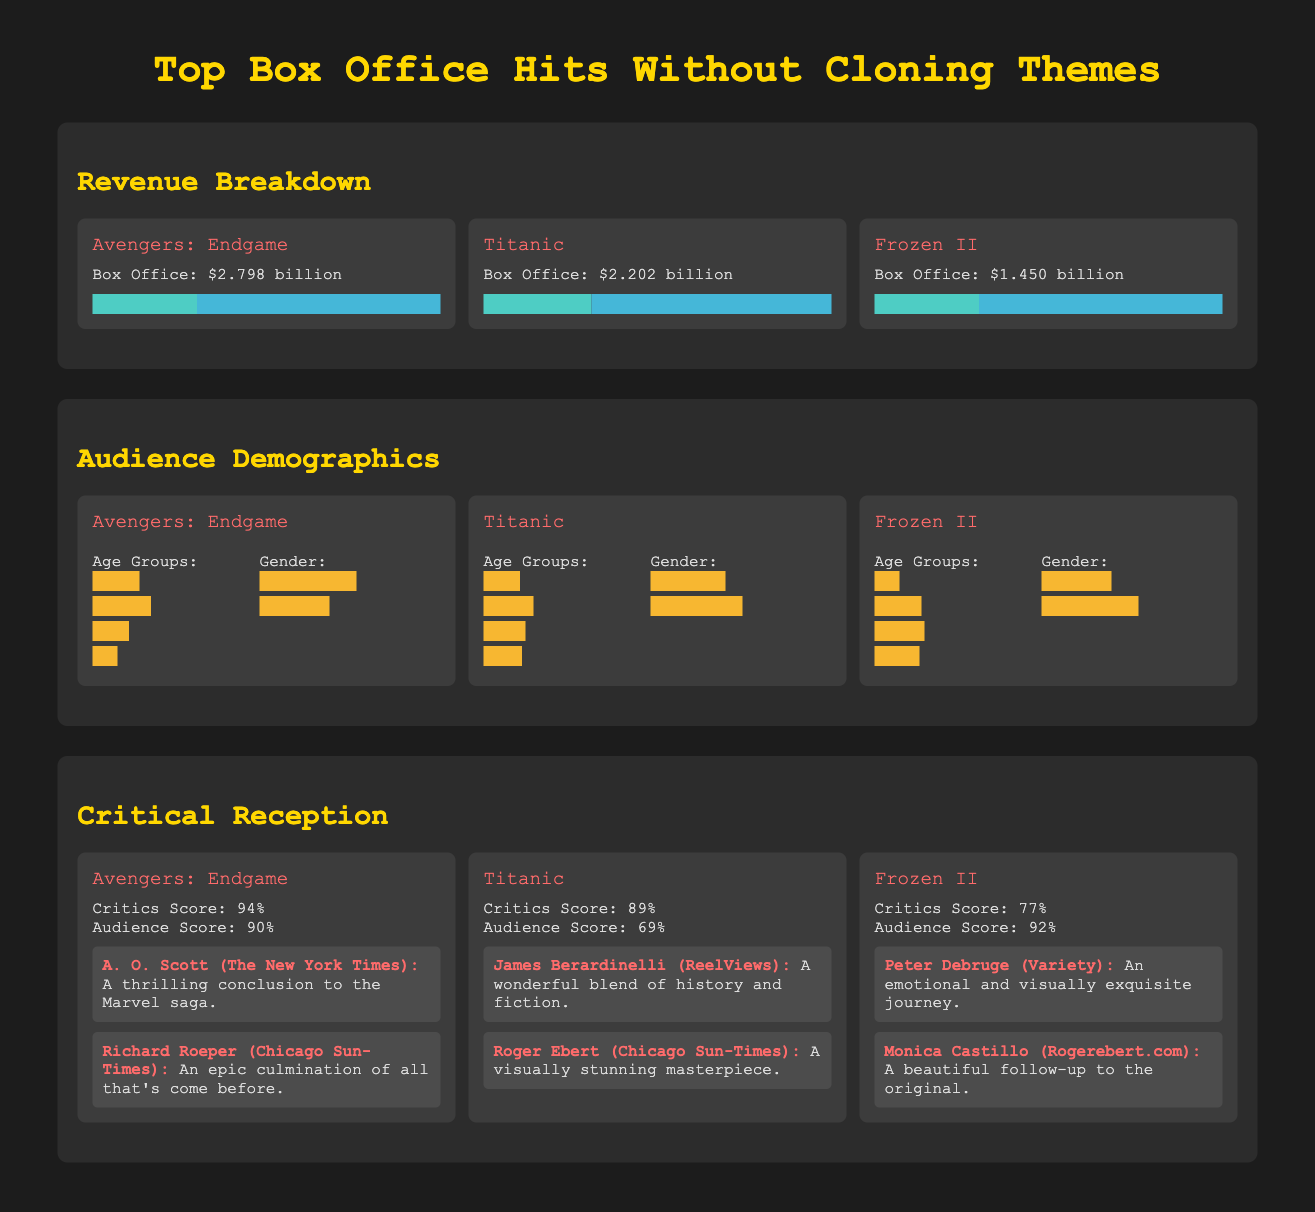What is the box office revenue of Avengers: Endgame? The box office revenue for Avengers: Endgame is specifically stated in the document.
Answer: $2.798 billion What percentage of Titanic’s revenue is from international markets? The document shows the revenue breakdown, indicating the percentage from international markets.
Answer: 69% Which movie has the highest audience score? The audience scores of all movies are provided, allowing a comparison to identify the highest.
Answer: Frozen II What is the critics' score for Titanic? The critics' score for Titanic is explicitly listed in the critical reception section of the document.
Answer: 89% Which age group represents the largest audience for Avengers: Endgame? The demographic breakdown illustrates the age group distribution for the movie.
Answer: 25-34 What percentage of Frozen II's audience is female? The audience demographics provide gender percentages, allowing identification of the female audience percentage for each movie.
Answer: 58% What are the names of the critics who reviewed Avengers: Endgame? The critical reception section details reviews along with the names of the critics.
Answer: A. O. Scott, Richard Roeper What is the title of the movie with the lowest box office revenue? The box office revenues are compared to determine which movie has the lowest total.
Answer: Frozen II What is the total box office revenue of the three movies combined? The total revenue can be calculated by adding the individual box office figures of the movies listed.
Answer: $6.450 billion What is the main theme being avoided in these top hits? The document focuses on the thematic element that is explicitly excluded from the selected films.
Answer: Cloning 